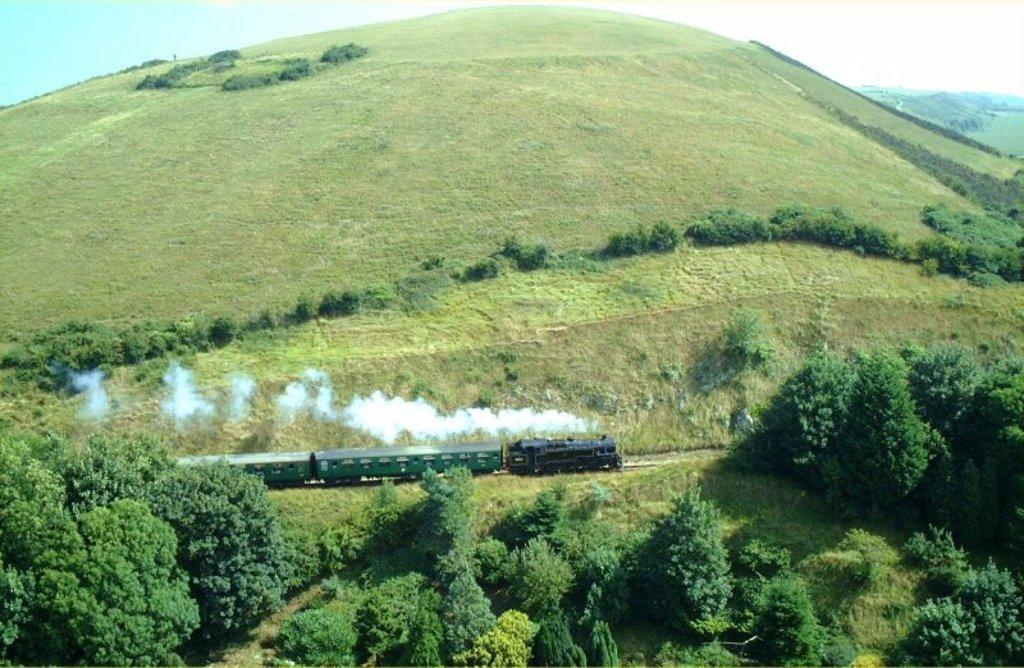Could you give a brief overview of what you see in this image? In this picture I can see there is a train moving here and there are trees here. There are mountains here in the backdrop and the sky is clear. 